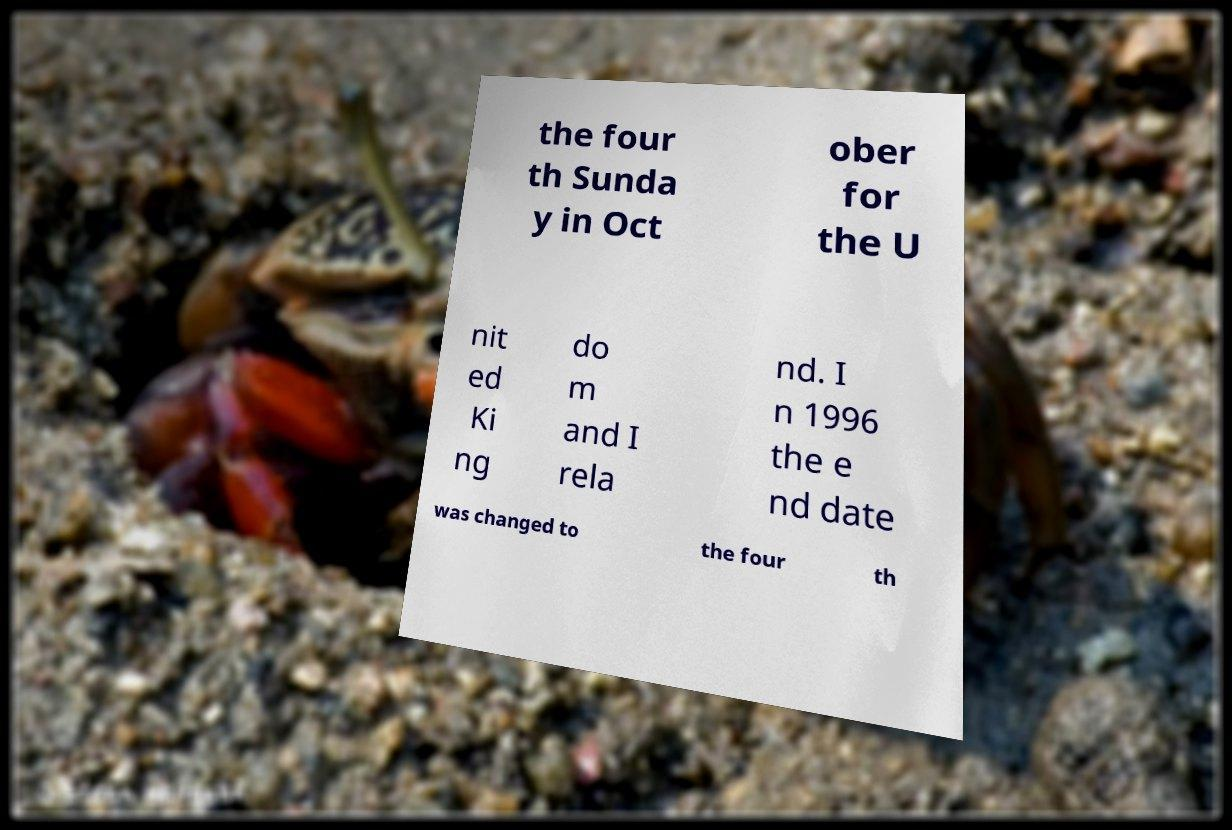Could you extract and type out the text from this image? the four th Sunda y in Oct ober for the U nit ed Ki ng do m and I rela nd. I n 1996 the e nd date was changed to the four th 